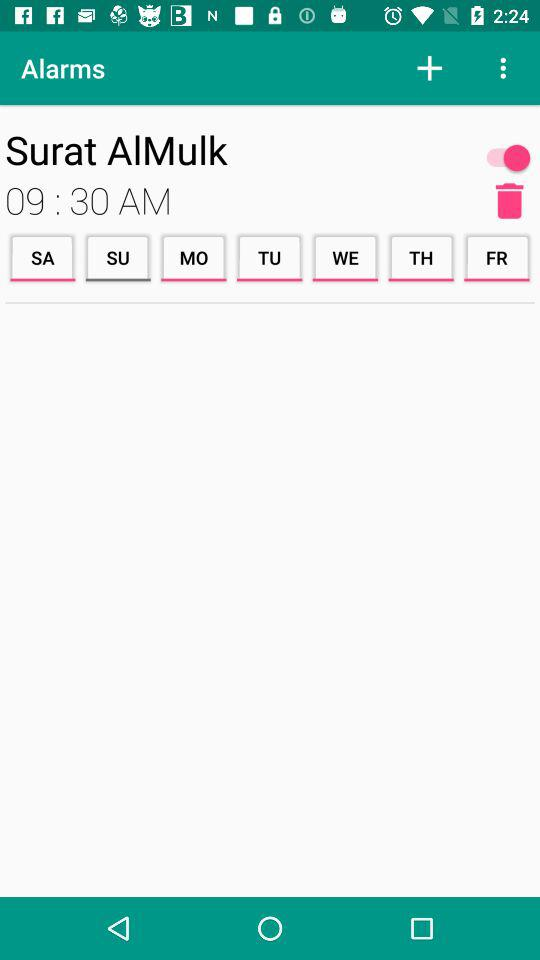Which alarm sound is selected?
When the provided information is insufficient, respond with <no answer>. <no answer> 